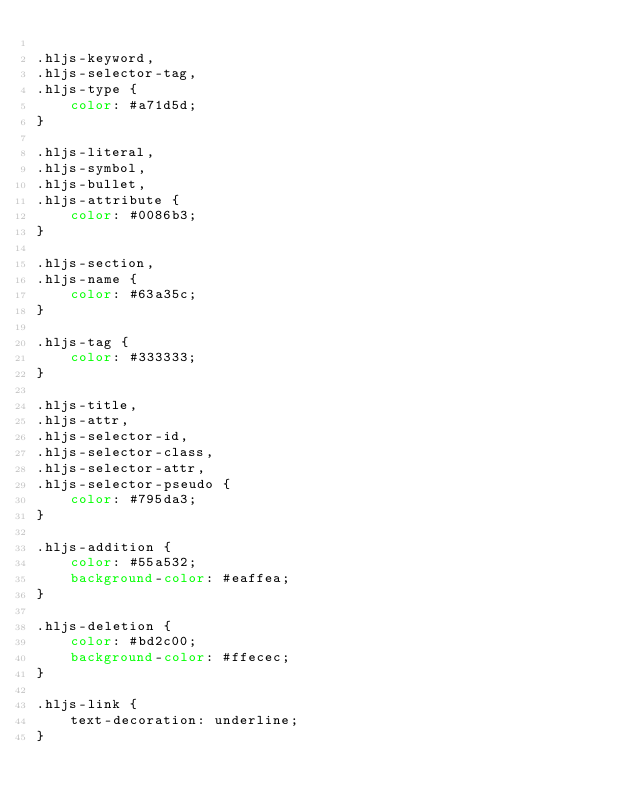Convert code to text. <code><loc_0><loc_0><loc_500><loc_500><_CSS_>
.hljs-keyword,
.hljs-selector-tag,
.hljs-type {
    color: #a71d5d;
}

.hljs-literal,
.hljs-symbol,
.hljs-bullet,
.hljs-attribute {
    color: #0086b3;
}

.hljs-section,
.hljs-name {
    color: #63a35c;
}

.hljs-tag {
    color: #333333;
}

.hljs-title,
.hljs-attr,
.hljs-selector-id,
.hljs-selector-class,
.hljs-selector-attr,
.hljs-selector-pseudo {
    color: #795da3;
}

.hljs-addition {
    color: #55a532;
    background-color: #eaffea;
}

.hljs-deletion {
    color: #bd2c00;
    background-color: #ffecec;
}

.hljs-link {
    text-decoration: underline;
}
</code> 